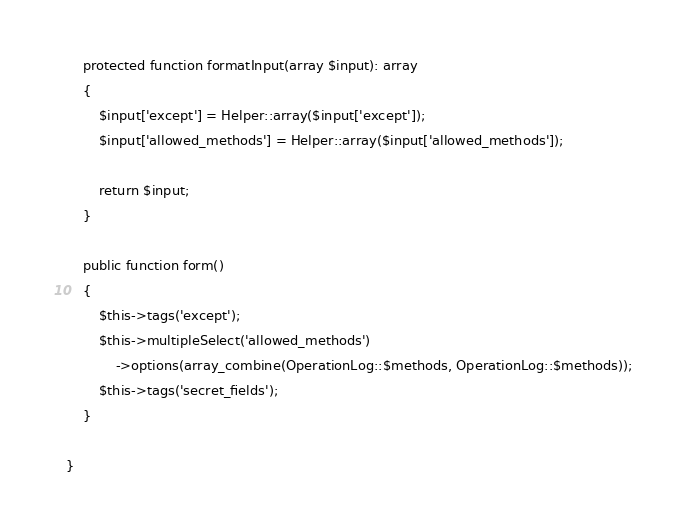<code> <loc_0><loc_0><loc_500><loc_500><_PHP_>    protected function formatInput(array $input): array
    {
        $input['except'] = Helper::array($input['except']);
        $input['allowed_methods'] = Helper::array($input['allowed_methods']);

        return $input;
    }

    public function form()
    {
        $this->tags('except');
        $this->multipleSelect('allowed_methods')
            ->options(array_combine(OperationLog::$methods, OperationLog::$methods));
        $this->tags('secret_fields');
    }

}
</code> 